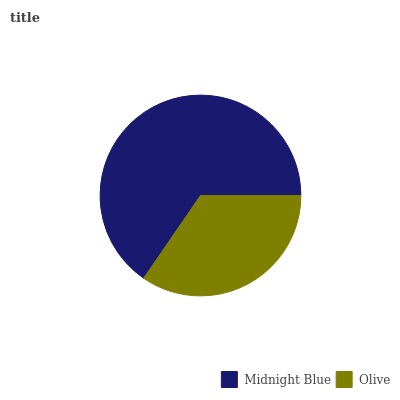Is Olive the minimum?
Answer yes or no. Yes. Is Midnight Blue the maximum?
Answer yes or no. Yes. Is Olive the maximum?
Answer yes or no. No. Is Midnight Blue greater than Olive?
Answer yes or no. Yes. Is Olive less than Midnight Blue?
Answer yes or no. Yes. Is Olive greater than Midnight Blue?
Answer yes or no. No. Is Midnight Blue less than Olive?
Answer yes or no. No. Is Midnight Blue the high median?
Answer yes or no. Yes. Is Olive the low median?
Answer yes or no. Yes. Is Olive the high median?
Answer yes or no. No. Is Midnight Blue the low median?
Answer yes or no. No. 